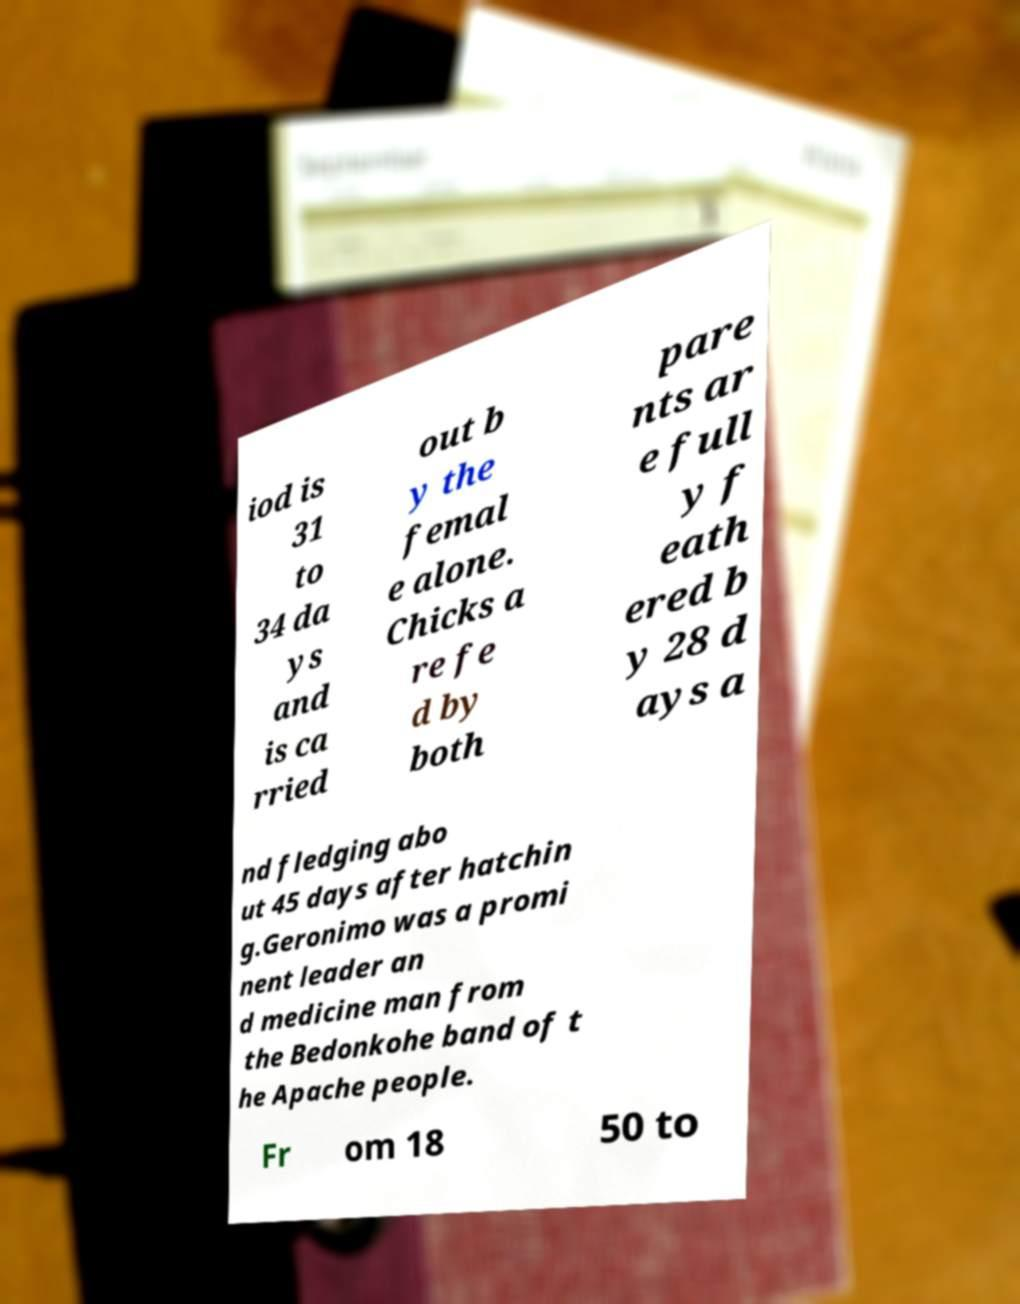Could you extract and type out the text from this image? iod is 31 to 34 da ys and is ca rried out b y the femal e alone. Chicks a re fe d by both pare nts ar e full y f eath ered b y 28 d ays a nd fledging abo ut 45 days after hatchin g.Geronimo was a promi nent leader an d medicine man from the Bedonkohe band of t he Apache people. Fr om 18 50 to 